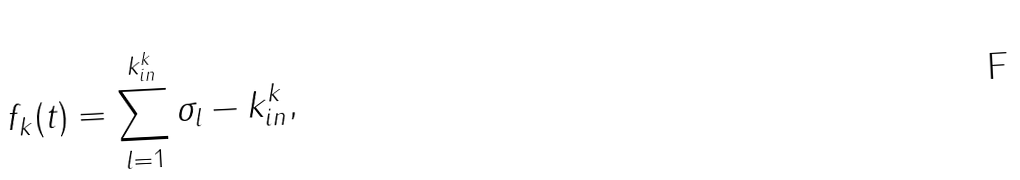Convert formula to latex. <formula><loc_0><loc_0><loc_500><loc_500>f _ { k } ( t ) = \sum _ { l = 1 } ^ { k _ { i n } ^ { k } } \sigma _ { l } - k _ { i n } ^ { k } ,</formula> 